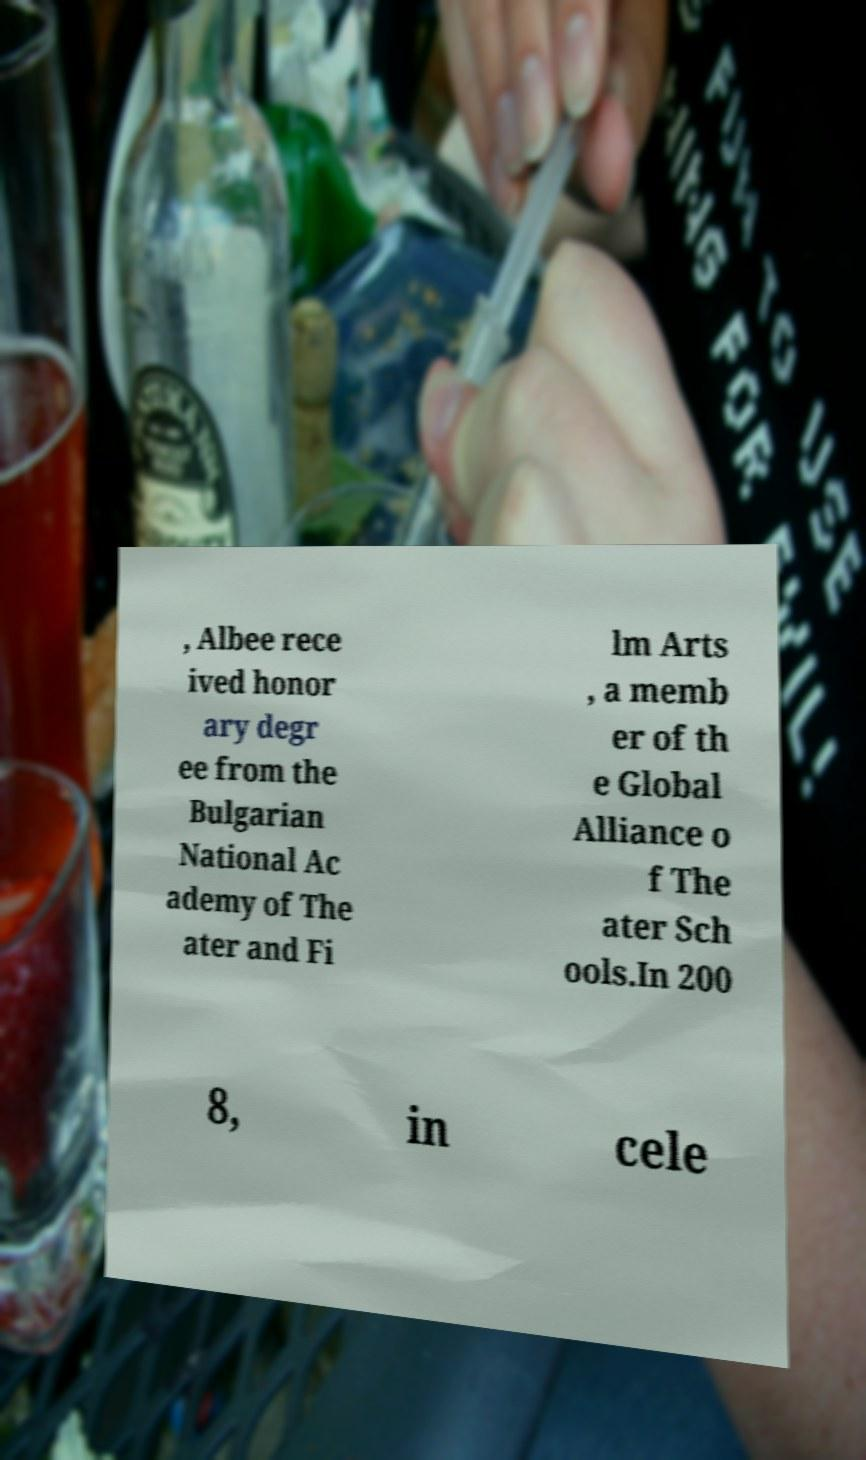There's text embedded in this image that I need extracted. Can you transcribe it verbatim? , Albee rece ived honor ary degr ee from the Bulgarian National Ac ademy of The ater and Fi lm Arts , a memb er of th e Global Alliance o f The ater Sch ools.In 200 8, in cele 